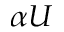Convert formula to latex. <formula><loc_0><loc_0><loc_500><loc_500>\alpha U</formula> 